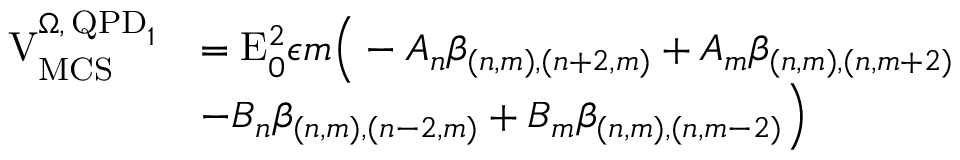Convert formula to latex. <formula><loc_0><loc_0><loc_500><loc_500>\begin{array} { r l } { V _ { M C S } ^ { \Omega , \, Q P D _ { 1 } } } & { = E _ { 0 } ^ { 2 } \epsilon m \left ( - A _ { n } \beta _ { ( n , m ) , ( n + 2 , m ) } + A _ { m } \beta _ { ( n , m ) , ( n , m + 2 ) } } \\ & { - B _ { n } \beta _ { ( n , m ) , ( n - 2 , m ) } + B _ { m } \beta _ { ( n , m ) , ( n , m - 2 ) } \right ) } \end{array}</formula> 